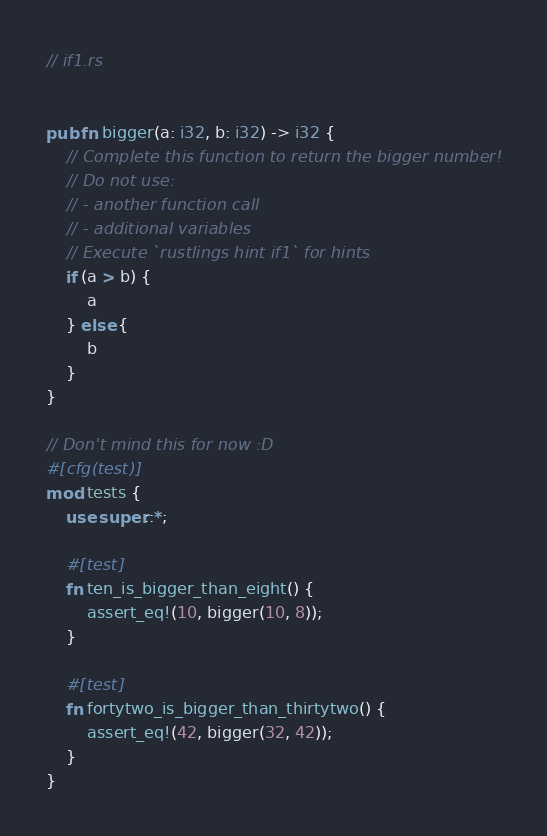<code> <loc_0><loc_0><loc_500><loc_500><_Rust_>// if1.rs


pub fn bigger(a: i32, b: i32) -> i32 {
    // Complete this function to return the bigger number!
    // Do not use:
    // - another function call
    // - additional variables
    // Execute `rustlings hint if1` for hints
    if (a > b) {
        a
    } else {
        b
    }
}

// Don't mind this for now :D
#[cfg(test)]
mod tests {
    use super::*;

    #[test]
    fn ten_is_bigger_than_eight() {
        assert_eq!(10, bigger(10, 8));
    }

    #[test]
    fn fortytwo_is_bigger_than_thirtytwo() {
        assert_eq!(42, bigger(32, 42));
    }
}
</code> 